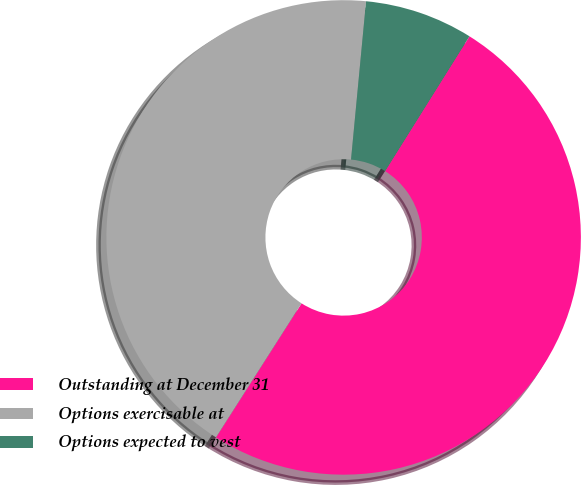Convert chart. <chart><loc_0><loc_0><loc_500><loc_500><pie_chart><fcel>Outstanding at December 31<fcel>Options exercisable at<fcel>Options expected to vest<nl><fcel>50.14%<fcel>42.47%<fcel>7.39%<nl></chart> 